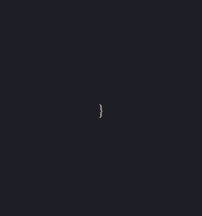Convert code to text. <code><loc_0><loc_0><loc_500><loc_500><_JavaScript_>}
</code> 